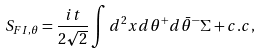<formula> <loc_0><loc_0><loc_500><loc_500>S _ { F I , \theta } & = \frac { i t } { 2 \sqrt { 2 } } \int d ^ { 2 } x d \theta ^ { + } d \bar { \theta } ^ { - } \Sigma + c . c ,</formula> 